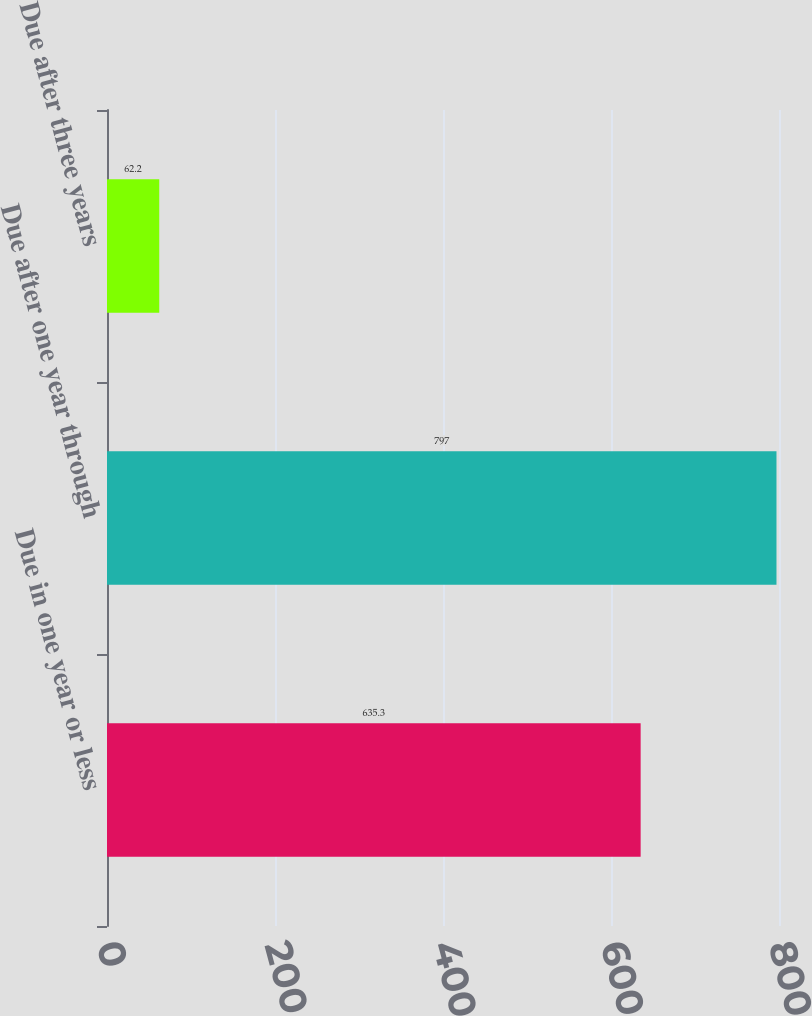<chart> <loc_0><loc_0><loc_500><loc_500><bar_chart><fcel>Due in one year or less<fcel>Due after one year through<fcel>Due after three years<nl><fcel>635.3<fcel>797<fcel>62.2<nl></chart> 